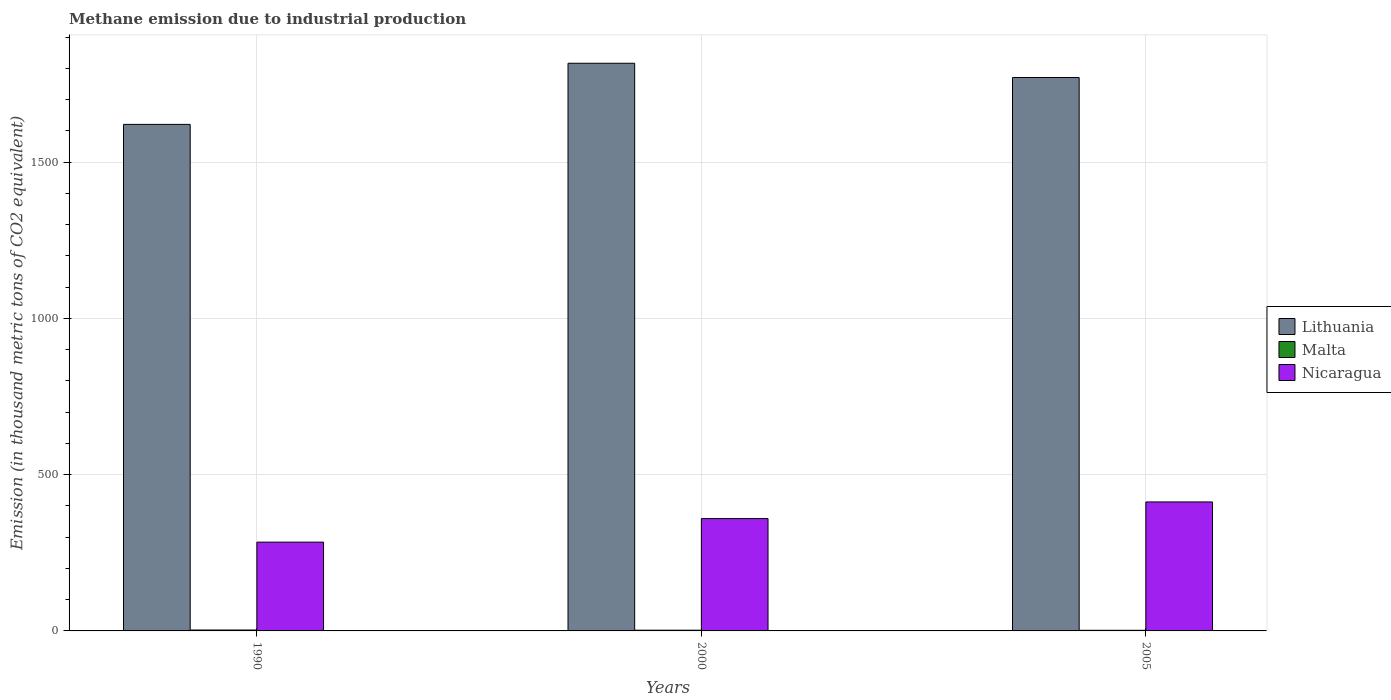How many groups of bars are there?
Your response must be concise. 3. Are the number of bars per tick equal to the number of legend labels?
Your response must be concise. Yes. How many bars are there on the 1st tick from the left?
Keep it short and to the point. 3. How many bars are there on the 1st tick from the right?
Your response must be concise. 3. In how many cases, is the number of bars for a given year not equal to the number of legend labels?
Provide a succinct answer. 0. What is the amount of methane emitted in Lithuania in 1990?
Offer a very short reply. 1620.9. Across all years, what is the maximum amount of methane emitted in Nicaragua?
Make the answer very short. 412.7. Across all years, what is the minimum amount of methane emitted in Nicaragua?
Keep it short and to the point. 284.1. In which year was the amount of methane emitted in Malta maximum?
Make the answer very short. 1990. In which year was the amount of methane emitted in Lithuania minimum?
Make the answer very short. 1990. What is the total amount of methane emitted in Nicaragua in the graph?
Offer a terse response. 1056.3. What is the difference between the amount of methane emitted in Malta in 2000 and that in 2005?
Give a very brief answer. 0.3. What is the difference between the amount of methane emitted in Lithuania in 2000 and the amount of methane emitted in Malta in 1990?
Your response must be concise. 1813.6. What is the average amount of methane emitted in Nicaragua per year?
Keep it short and to the point. 352.1. In the year 2000, what is the difference between the amount of methane emitted in Nicaragua and amount of methane emitted in Lithuania?
Your response must be concise. -1457. What is the ratio of the amount of methane emitted in Nicaragua in 2000 to that in 2005?
Your response must be concise. 0.87. What is the difference between the highest and the second highest amount of methane emitted in Nicaragua?
Give a very brief answer. 53.2. What is the difference between the highest and the lowest amount of methane emitted in Lithuania?
Offer a very short reply. 195.6. In how many years, is the amount of methane emitted in Nicaragua greater than the average amount of methane emitted in Nicaragua taken over all years?
Your answer should be compact. 2. Is the sum of the amount of methane emitted in Lithuania in 1990 and 2005 greater than the maximum amount of methane emitted in Malta across all years?
Your response must be concise. Yes. What does the 3rd bar from the left in 2005 represents?
Your answer should be very brief. Nicaragua. What does the 1st bar from the right in 1990 represents?
Provide a short and direct response. Nicaragua. What is the difference between two consecutive major ticks on the Y-axis?
Give a very brief answer. 500. Does the graph contain any zero values?
Your answer should be compact. No. Does the graph contain grids?
Keep it short and to the point. Yes. Where does the legend appear in the graph?
Offer a terse response. Center right. How many legend labels are there?
Make the answer very short. 3. What is the title of the graph?
Your response must be concise. Methane emission due to industrial production. What is the label or title of the X-axis?
Ensure brevity in your answer.  Years. What is the label or title of the Y-axis?
Your answer should be compact. Emission (in thousand metric tons of CO2 equivalent). What is the Emission (in thousand metric tons of CO2 equivalent) of Lithuania in 1990?
Your answer should be compact. 1620.9. What is the Emission (in thousand metric tons of CO2 equivalent) in Nicaragua in 1990?
Provide a short and direct response. 284.1. What is the Emission (in thousand metric tons of CO2 equivalent) of Lithuania in 2000?
Keep it short and to the point. 1816.5. What is the Emission (in thousand metric tons of CO2 equivalent) in Nicaragua in 2000?
Make the answer very short. 359.5. What is the Emission (in thousand metric tons of CO2 equivalent) of Lithuania in 2005?
Provide a short and direct response. 1770.9. What is the Emission (in thousand metric tons of CO2 equivalent) of Nicaragua in 2005?
Give a very brief answer. 412.7. Across all years, what is the maximum Emission (in thousand metric tons of CO2 equivalent) of Lithuania?
Provide a short and direct response. 1816.5. Across all years, what is the maximum Emission (in thousand metric tons of CO2 equivalent) in Nicaragua?
Your answer should be very brief. 412.7. Across all years, what is the minimum Emission (in thousand metric tons of CO2 equivalent) of Lithuania?
Your answer should be compact. 1620.9. Across all years, what is the minimum Emission (in thousand metric tons of CO2 equivalent) in Nicaragua?
Your answer should be compact. 284.1. What is the total Emission (in thousand metric tons of CO2 equivalent) in Lithuania in the graph?
Give a very brief answer. 5208.3. What is the total Emission (in thousand metric tons of CO2 equivalent) in Nicaragua in the graph?
Offer a very short reply. 1056.3. What is the difference between the Emission (in thousand metric tons of CO2 equivalent) of Lithuania in 1990 and that in 2000?
Make the answer very short. -195.6. What is the difference between the Emission (in thousand metric tons of CO2 equivalent) of Nicaragua in 1990 and that in 2000?
Provide a short and direct response. -75.4. What is the difference between the Emission (in thousand metric tons of CO2 equivalent) of Lithuania in 1990 and that in 2005?
Keep it short and to the point. -150. What is the difference between the Emission (in thousand metric tons of CO2 equivalent) of Nicaragua in 1990 and that in 2005?
Make the answer very short. -128.6. What is the difference between the Emission (in thousand metric tons of CO2 equivalent) of Lithuania in 2000 and that in 2005?
Give a very brief answer. 45.6. What is the difference between the Emission (in thousand metric tons of CO2 equivalent) in Malta in 2000 and that in 2005?
Keep it short and to the point. 0.3. What is the difference between the Emission (in thousand metric tons of CO2 equivalent) in Nicaragua in 2000 and that in 2005?
Keep it short and to the point. -53.2. What is the difference between the Emission (in thousand metric tons of CO2 equivalent) of Lithuania in 1990 and the Emission (in thousand metric tons of CO2 equivalent) of Malta in 2000?
Ensure brevity in your answer.  1618.6. What is the difference between the Emission (in thousand metric tons of CO2 equivalent) in Lithuania in 1990 and the Emission (in thousand metric tons of CO2 equivalent) in Nicaragua in 2000?
Provide a short and direct response. 1261.4. What is the difference between the Emission (in thousand metric tons of CO2 equivalent) in Malta in 1990 and the Emission (in thousand metric tons of CO2 equivalent) in Nicaragua in 2000?
Ensure brevity in your answer.  -356.6. What is the difference between the Emission (in thousand metric tons of CO2 equivalent) of Lithuania in 1990 and the Emission (in thousand metric tons of CO2 equivalent) of Malta in 2005?
Provide a short and direct response. 1618.9. What is the difference between the Emission (in thousand metric tons of CO2 equivalent) of Lithuania in 1990 and the Emission (in thousand metric tons of CO2 equivalent) of Nicaragua in 2005?
Ensure brevity in your answer.  1208.2. What is the difference between the Emission (in thousand metric tons of CO2 equivalent) of Malta in 1990 and the Emission (in thousand metric tons of CO2 equivalent) of Nicaragua in 2005?
Offer a very short reply. -409.8. What is the difference between the Emission (in thousand metric tons of CO2 equivalent) of Lithuania in 2000 and the Emission (in thousand metric tons of CO2 equivalent) of Malta in 2005?
Make the answer very short. 1814.5. What is the difference between the Emission (in thousand metric tons of CO2 equivalent) of Lithuania in 2000 and the Emission (in thousand metric tons of CO2 equivalent) of Nicaragua in 2005?
Keep it short and to the point. 1403.8. What is the difference between the Emission (in thousand metric tons of CO2 equivalent) of Malta in 2000 and the Emission (in thousand metric tons of CO2 equivalent) of Nicaragua in 2005?
Your answer should be compact. -410.4. What is the average Emission (in thousand metric tons of CO2 equivalent) of Lithuania per year?
Offer a terse response. 1736.1. What is the average Emission (in thousand metric tons of CO2 equivalent) of Malta per year?
Your response must be concise. 2.4. What is the average Emission (in thousand metric tons of CO2 equivalent) of Nicaragua per year?
Offer a terse response. 352.1. In the year 1990, what is the difference between the Emission (in thousand metric tons of CO2 equivalent) of Lithuania and Emission (in thousand metric tons of CO2 equivalent) of Malta?
Offer a terse response. 1618. In the year 1990, what is the difference between the Emission (in thousand metric tons of CO2 equivalent) in Lithuania and Emission (in thousand metric tons of CO2 equivalent) in Nicaragua?
Provide a succinct answer. 1336.8. In the year 1990, what is the difference between the Emission (in thousand metric tons of CO2 equivalent) of Malta and Emission (in thousand metric tons of CO2 equivalent) of Nicaragua?
Ensure brevity in your answer.  -281.2. In the year 2000, what is the difference between the Emission (in thousand metric tons of CO2 equivalent) of Lithuania and Emission (in thousand metric tons of CO2 equivalent) of Malta?
Provide a succinct answer. 1814.2. In the year 2000, what is the difference between the Emission (in thousand metric tons of CO2 equivalent) of Lithuania and Emission (in thousand metric tons of CO2 equivalent) of Nicaragua?
Keep it short and to the point. 1457. In the year 2000, what is the difference between the Emission (in thousand metric tons of CO2 equivalent) of Malta and Emission (in thousand metric tons of CO2 equivalent) of Nicaragua?
Offer a very short reply. -357.2. In the year 2005, what is the difference between the Emission (in thousand metric tons of CO2 equivalent) in Lithuania and Emission (in thousand metric tons of CO2 equivalent) in Malta?
Your response must be concise. 1768.9. In the year 2005, what is the difference between the Emission (in thousand metric tons of CO2 equivalent) of Lithuania and Emission (in thousand metric tons of CO2 equivalent) of Nicaragua?
Ensure brevity in your answer.  1358.2. In the year 2005, what is the difference between the Emission (in thousand metric tons of CO2 equivalent) in Malta and Emission (in thousand metric tons of CO2 equivalent) in Nicaragua?
Your response must be concise. -410.7. What is the ratio of the Emission (in thousand metric tons of CO2 equivalent) in Lithuania in 1990 to that in 2000?
Keep it short and to the point. 0.89. What is the ratio of the Emission (in thousand metric tons of CO2 equivalent) in Malta in 1990 to that in 2000?
Ensure brevity in your answer.  1.26. What is the ratio of the Emission (in thousand metric tons of CO2 equivalent) of Nicaragua in 1990 to that in 2000?
Your answer should be compact. 0.79. What is the ratio of the Emission (in thousand metric tons of CO2 equivalent) in Lithuania in 1990 to that in 2005?
Offer a very short reply. 0.92. What is the ratio of the Emission (in thousand metric tons of CO2 equivalent) of Malta in 1990 to that in 2005?
Your response must be concise. 1.45. What is the ratio of the Emission (in thousand metric tons of CO2 equivalent) of Nicaragua in 1990 to that in 2005?
Your answer should be compact. 0.69. What is the ratio of the Emission (in thousand metric tons of CO2 equivalent) of Lithuania in 2000 to that in 2005?
Your answer should be compact. 1.03. What is the ratio of the Emission (in thousand metric tons of CO2 equivalent) in Malta in 2000 to that in 2005?
Your answer should be very brief. 1.15. What is the ratio of the Emission (in thousand metric tons of CO2 equivalent) in Nicaragua in 2000 to that in 2005?
Make the answer very short. 0.87. What is the difference between the highest and the second highest Emission (in thousand metric tons of CO2 equivalent) of Lithuania?
Offer a terse response. 45.6. What is the difference between the highest and the second highest Emission (in thousand metric tons of CO2 equivalent) in Nicaragua?
Offer a very short reply. 53.2. What is the difference between the highest and the lowest Emission (in thousand metric tons of CO2 equivalent) in Lithuania?
Give a very brief answer. 195.6. What is the difference between the highest and the lowest Emission (in thousand metric tons of CO2 equivalent) in Nicaragua?
Provide a succinct answer. 128.6. 